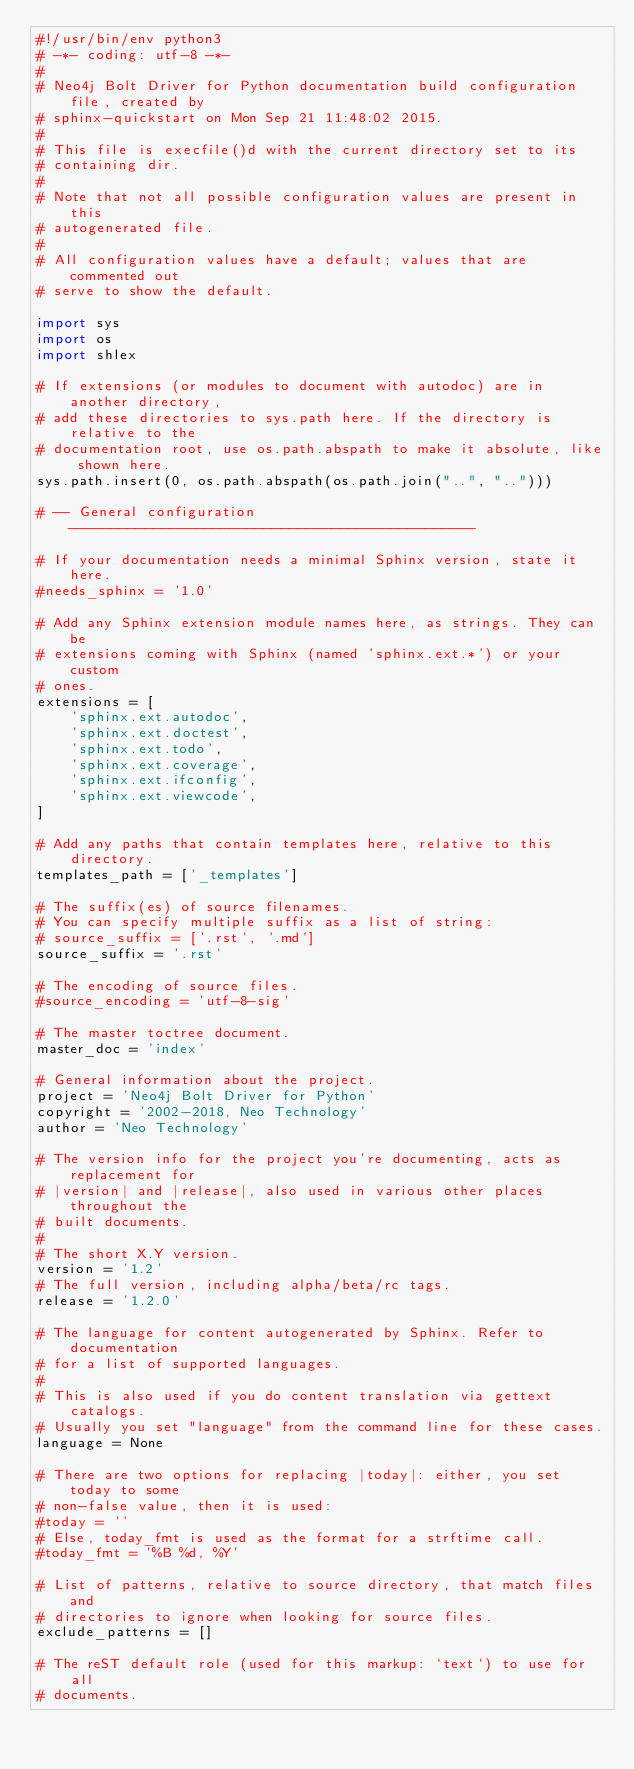Convert code to text. <code><loc_0><loc_0><loc_500><loc_500><_Python_>#!/usr/bin/env python3
# -*- coding: utf-8 -*-
#
# Neo4j Bolt Driver for Python documentation build configuration file, created by
# sphinx-quickstart on Mon Sep 21 11:48:02 2015.
#
# This file is execfile()d with the current directory set to its
# containing dir.
#
# Note that not all possible configuration values are present in this
# autogenerated file.
#
# All configuration values have a default; values that are commented out
# serve to show the default.

import sys
import os
import shlex

# If extensions (or modules to document with autodoc) are in another directory,
# add these directories to sys.path here. If the directory is relative to the
# documentation root, use os.path.abspath to make it absolute, like shown here.
sys.path.insert(0, os.path.abspath(os.path.join("..", "..")))

# -- General configuration ------------------------------------------------

# If your documentation needs a minimal Sphinx version, state it here.
#needs_sphinx = '1.0'

# Add any Sphinx extension module names here, as strings. They can be
# extensions coming with Sphinx (named 'sphinx.ext.*') or your custom
# ones.
extensions = [
    'sphinx.ext.autodoc',
    'sphinx.ext.doctest',
    'sphinx.ext.todo',
    'sphinx.ext.coverage',
    'sphinx.ext.ifconfig',
    'sphinx.ext.viewcode',
]

# Add any paths that contain templates here, relative to this directory.
templates_path = ['_templates']

# The suffix(es) of source filenames.
# You can specify multiple suffix as a list of string:
# source_suffix = ['.rst', '.md']
source_suffix = '.rst'

# The encoding of source files.
#source_encoding = 'utf-8-sig'

# The master toctree document.
master_doc = 'index'

# General information about the project.
project = 'Neo4j Bolt Driver for Python'
copyright = '2002-2018, Neo Technology'
author = 'Neo Technology'

# The version info for the project you're documenting, acts as replacement for
# |version| and |release|, also used in various other places throughout the
# built documents.
#
# The short X.Y version.
version = '1.2'
# The full version, including alpha/beta/rc tags.
release = '1.2.0'

# The language for content autogenerated by Sphinx. Refer to documentation
# for a list of supported languages.
#
# This is also used if you do content translation via gettext catalogs.
# Usually you set "language" from the command line for these cases.
language = None

# There are two options for replacing |today|: either, you set today to some
# non-false value, then it is used:
#today = ''
# Else, today_fmt is used as the format for a strftime call.
#today_fmt = '%B %d, %Y'

# List of patterns, relative to source directory, that match files and
# directories to ignore when looking for source files.
exclude_patterns = []

# The reST default role (used for this markup: `text`) to use for all
# documents.</code> 